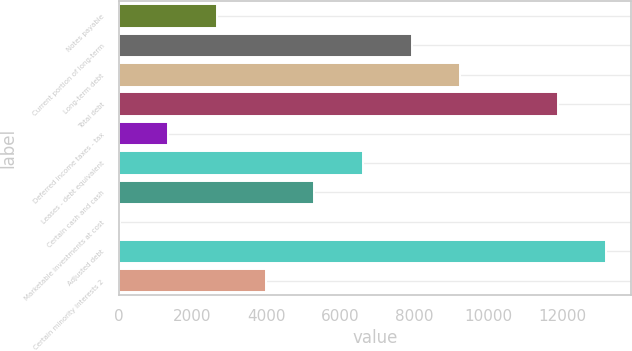<chart> <loc_0><loc_0><loc_500><loc_500><bar_chart><fcel>Notes payable<fcel>Current portion of long-term<fcel>Long-term debt<fcel>Total debt<fcel>Deferred income taxes - tax<fcel>Leases - debt equivalent<fcel>Certain cash and cash<fcel>Marketable investments at cost<fcel>Adjusted debt<fcel>Certain minority interests 2<nl><fcel>2659.6<fcel>7930.8<fcel>9248.6<fcel>11884.2<fcel>1341.8<fcel>6613<fcel>5295.2<fcel>24<fcel>13202<fcel>3977.4<nl></chart> 